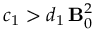Convert formula to latex. <formula><loc_0><loc_0><loc_500><loc_500>c _ { 1 } > d _ { 1 } \, { B } _ { 0 } ^ { 2 }</formula> 